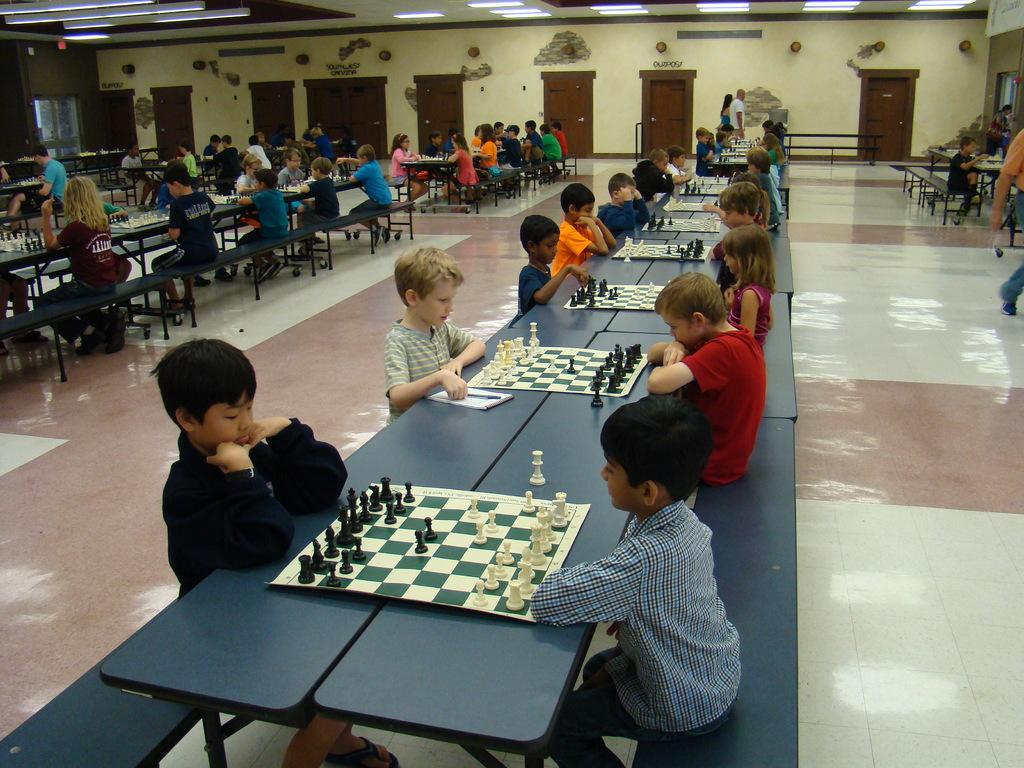How many people are in the image? There is a group of people in the image. What are the people doing in the image? The people are sitting on a bench and playing chess. What can be seen in the background of the image? There are doors visible in the image. What is visible at the top of the image? There are lights visible at the top of the image. Is there any blood visible on the chessboard in the image? No, there is no blood visible on the chessboard in the image. Can you tell me how the brake system of the bench works in the image? There is no mention of a bench with a brake system in the image, so it is not possible to answer that question. 